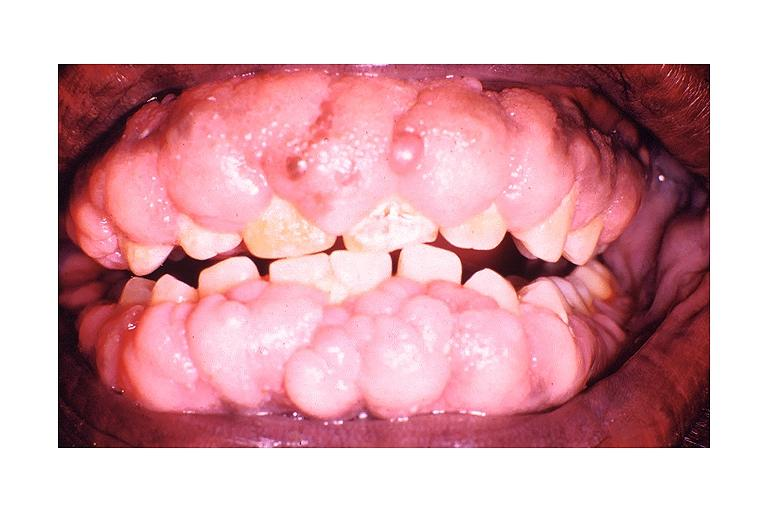s this good yellow color slide induced gingival hyperplasia?
Answer the question using a single word or phrase. No 